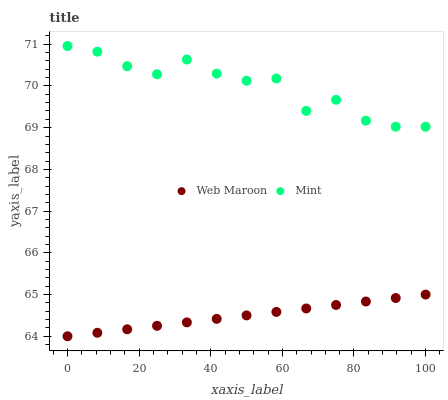Does Web Maroon have the minimum area under the curve?
Answer yes or no. Yes. Does Mint have the maximum area under the curve?
Answer yes or no. Yes. Does Web Maroon have the maximum area under the curve?
Answer yes or no. No. Is Web Maroon the smoothest?
Answer yes or no. Yes. Is Mint the roughest?
Answer yes or no. Yes. Is Web Maroon the roughest?
Answer yes or no. No. Does Web Maroon have the lowest value?
Answer yes or no. Yes. Does Mint have the highest value?
Answer yes or no. Yes. Does Web Maroon have the highest value?
Answer yes or no. No. Is Web Maroon less than Mint?
Answer yes or no. Yes. Is Mint greater than Web Maroon?
Answer yes or no. Yes. Does Web Maroon intersect Mint?
Answer yes or no. No. 